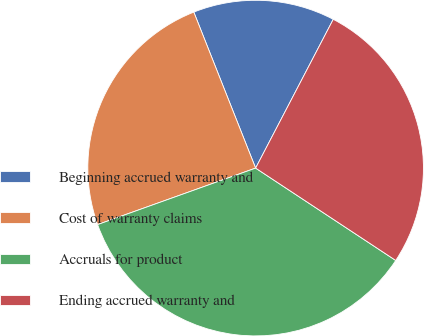<chart> <loc_0><loc_0><loc_500><loc_500><pie_chart><fcel>Beginning accrued warranty and<fcel>Cost of warranty claims<fcel>Accruals for product<fcel>Ending accrued warranty and<nl><fcel>13.66%<fcel>24.46%<fcel>35.26%<fcel>26.62%<nl></chart> 